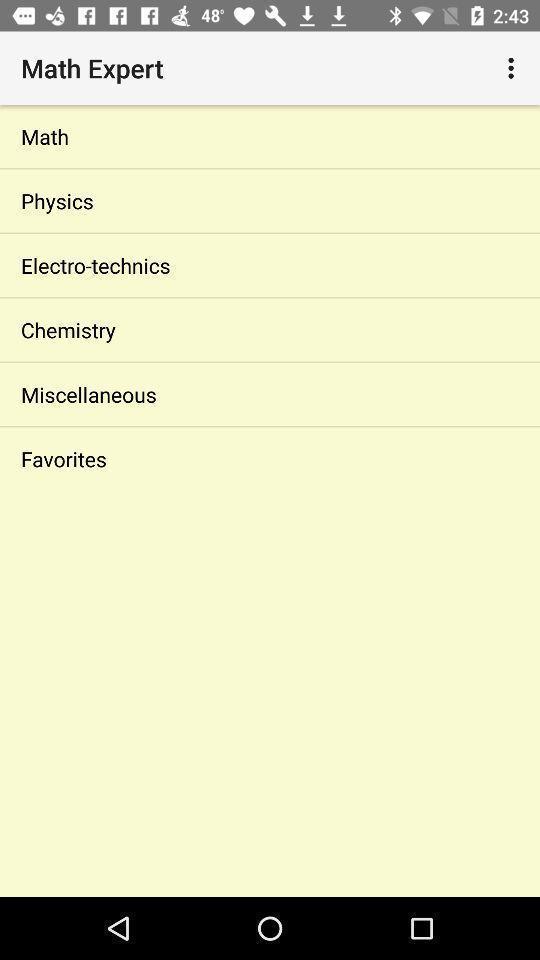Describe the key features of this screenshot. Page displays different subjects in app. 